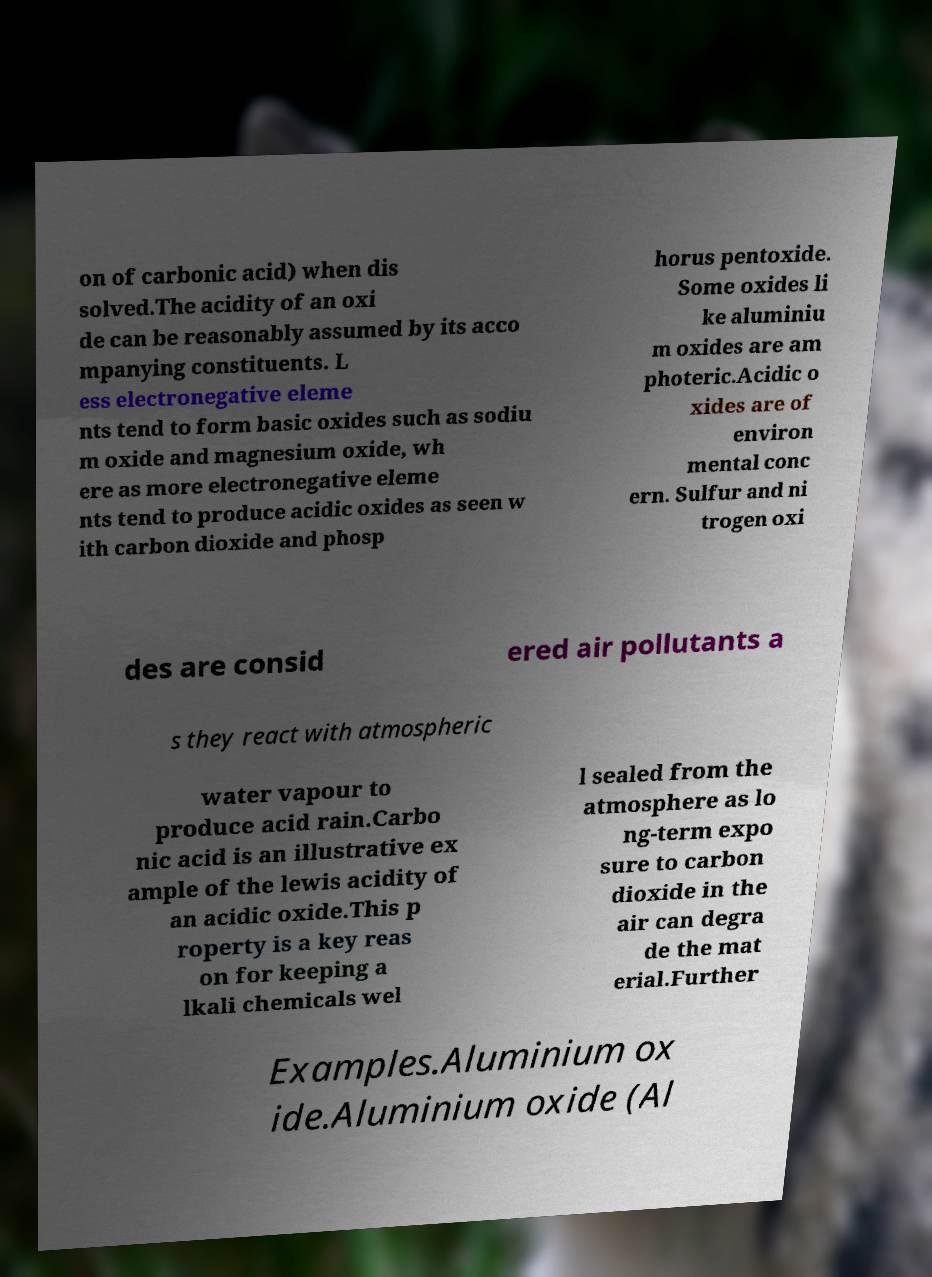Could you assist in decoding the text presented in this image and type it out clearly? on of carbonic acid) when dis solved.The acidity of an oxi de can be reasonably assumed by its acco mpanying constituents. L ess electronegative eleme nts tend to form basic oxides such as sodiu m oxide and magnesium oxide, wh ere as more electronegative eleme nts tend to produce acidic oxides as seen w ith carbon dioxide and phosp horus pentoxide. Some oxides li ke aluminiu m oxides are am photeric.Acidic o xides are of environ mental conc ern. Sulfur and ni trogen oxi des are consid ered air pollutants a s they react with atmospheric water vapour to produce acid rain.Carbo nic acid is an illustrative ex ample of the lewis acidity of an acidic oxide.This p roperty is a key reas on for keeping a lkali chemicals wel l sealed from the atmosphere as lo ng-term expo sure to carbon dioxide in the air can degra de the mat erial.Further Examples.Aluminium ox ide.Aluminium oxide (Al 